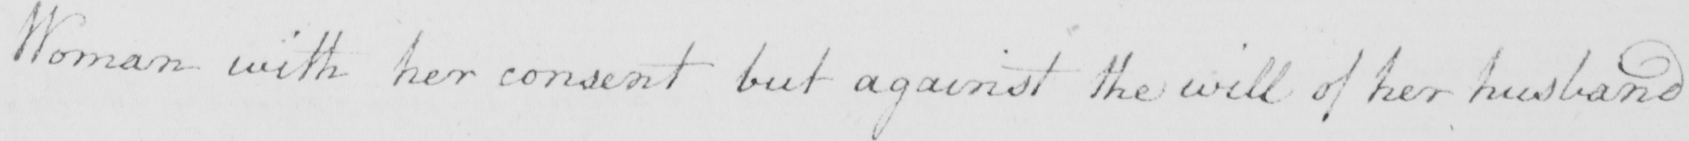Can you tell me what this handwritten text says? Woman with her consent but against the will of her husband 